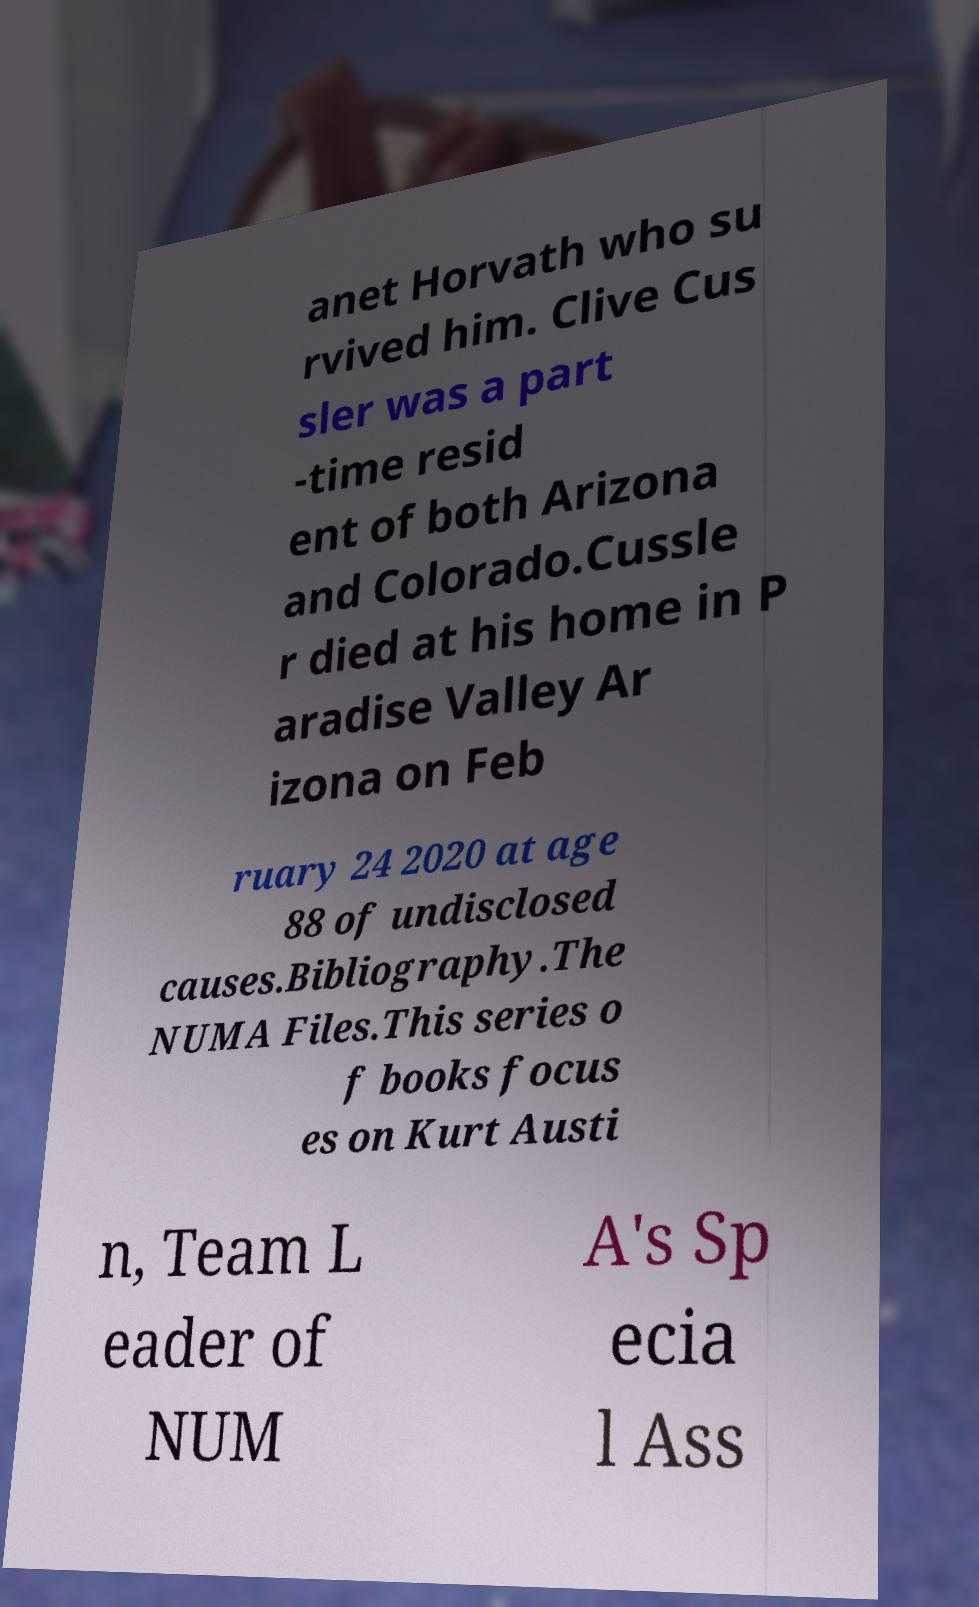Please identify and transcribe the text found in this image. anet Horvath who su rvived him. Clive Cus sler was a part -time resid ent of both Arizona and Colorado.Cussle r died at his home in P aradise Valley Ar izona on Feb ruary 24 2020 at age 88 of undisclosed causes.Bibliography.The NUMA Files.This series o f books focus es on Kurt Austi n, Team L eader of NUM A's Sp ecia l Ass 